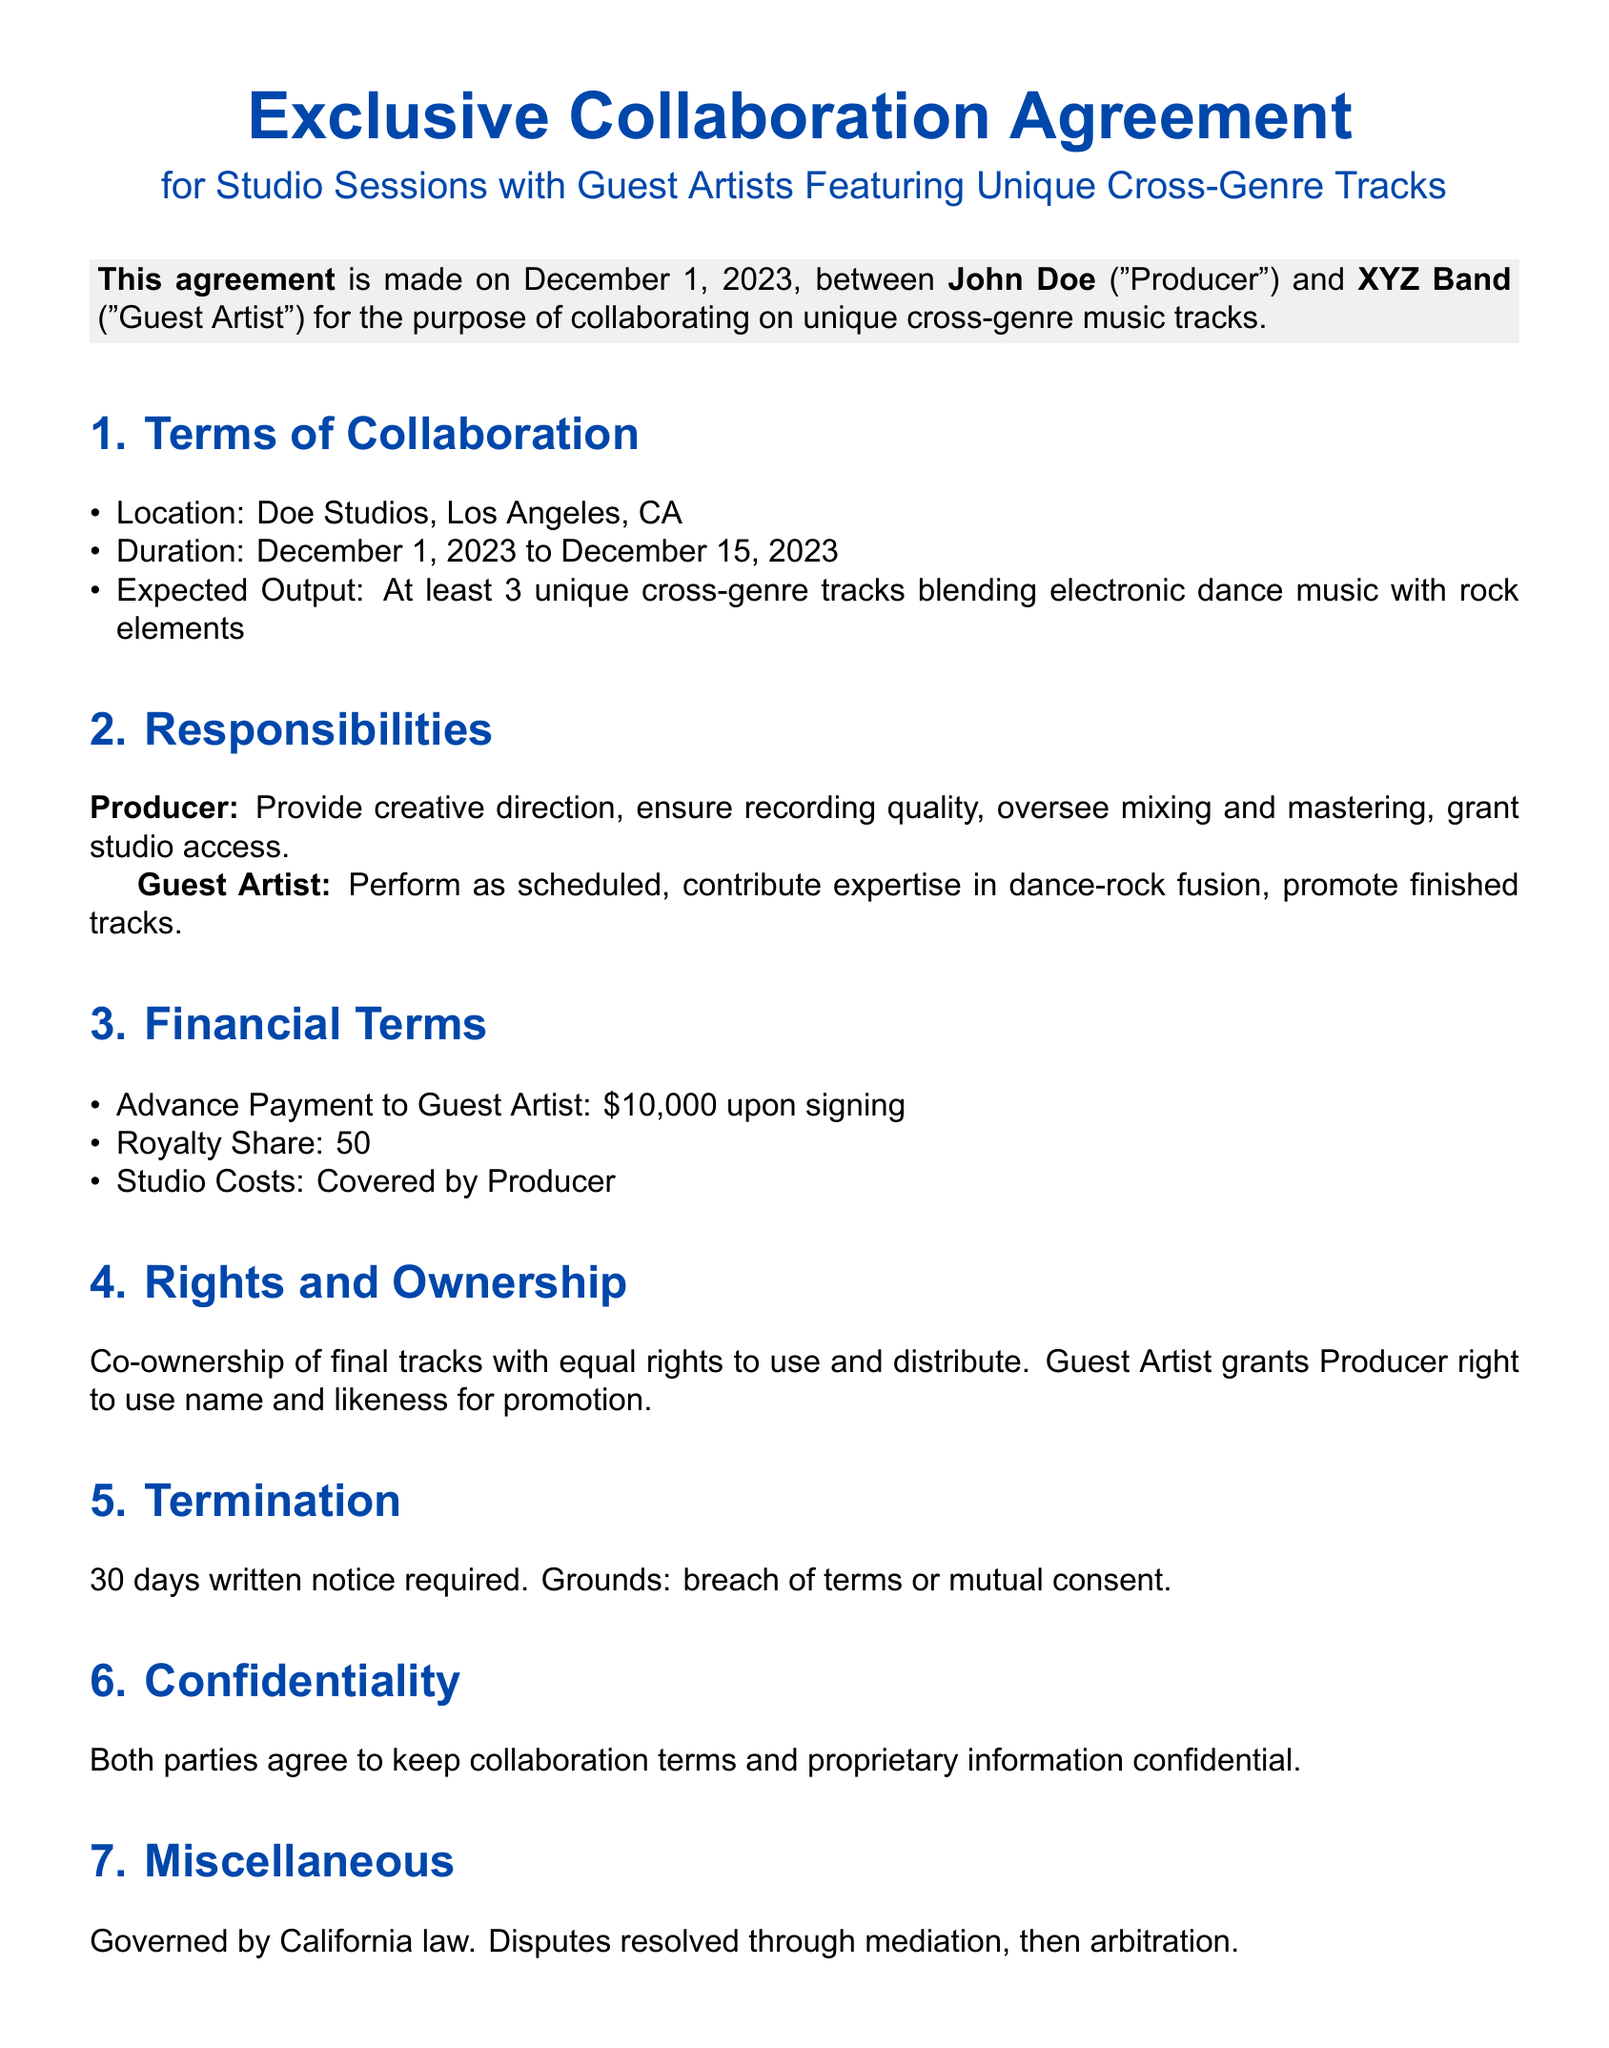what is the date of the agreement? The date of the agreement is mentioned at the beginning of the document as December 1, 2023.
Answer: December 1, 2023 who is the Producer in the agreement? The agreement identifies John Doe as the Producer.
Answer: John Doe what is the advance payment amount to the Guest Artist? The advance payment amount specified in the financial terms section is $10,000.
Answer: $10,000 how many unique cross-genre tracks are expected? The document states that at least 3 unique cross-genre tracks are expected as an output.
Answer: 3 what is the duration of the collaboration? The duration of the collaboration is specified as from December 1, 2023 to December 15, 2023.
Answer: December 1, 2023 to December 15, 2023 what rights does the Guest Artist grant to the Producer? The Guest Artist grants the Producer the right to use the name and likeness for promotion.
Answer: Right to use name and likeness for promotion what is required for termination of the agreement? The document indicates that 30 days written notice is required for termination.
Answer: 30 days written notice which law governs the agreement? The governing law of the agreement is specified as California law.
Answer: California law 